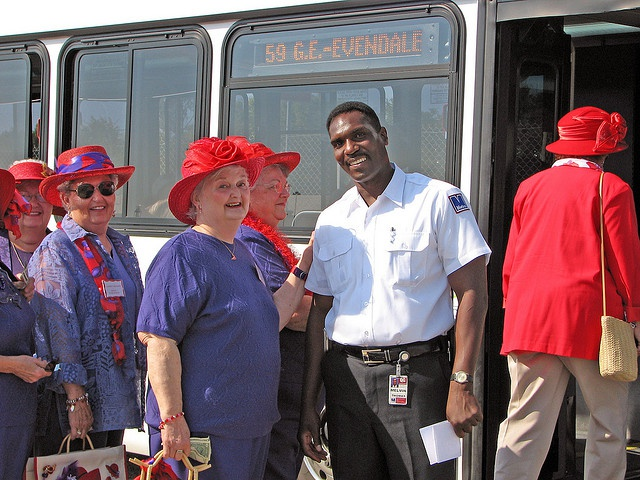Describe the objects in this image and their specific colors. I can see bus in white, black, and gray tones, people in white, black, darkgray, and gray tones, people in white, salmon, brown, red, and gray tones, people in white, navy, brown, purple, and blue tones, and people in white, purple, black, navy, and blue tones in this image. 